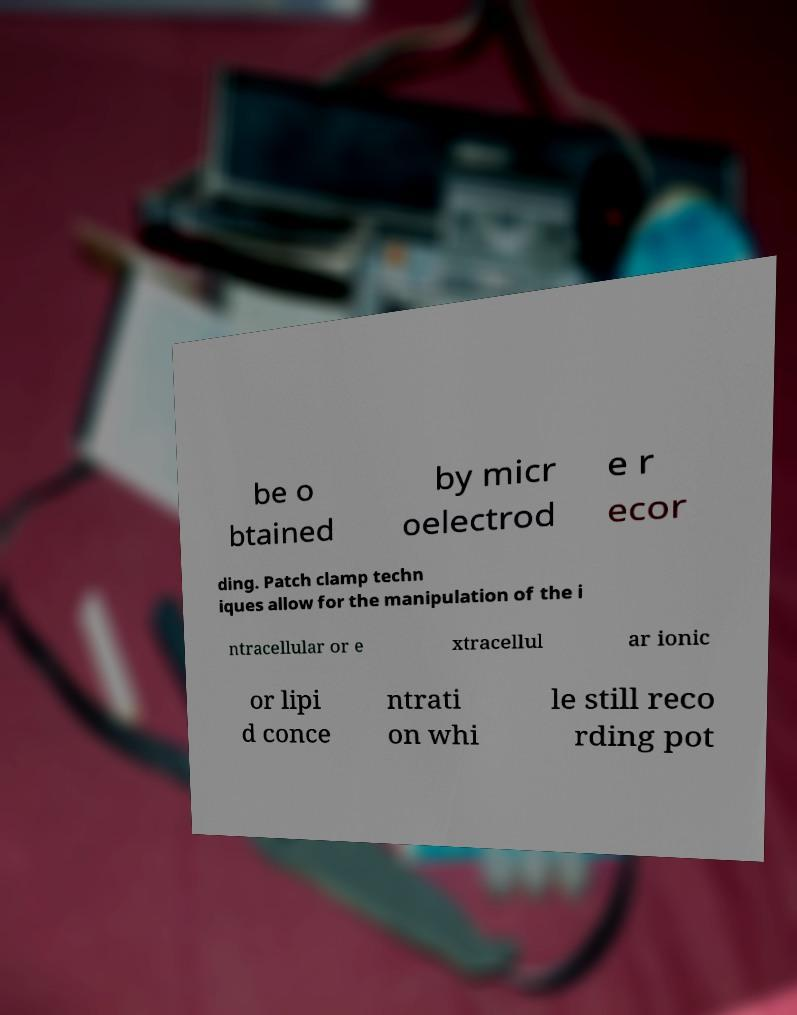For documentation purposes, I need the text within this image transcribed. Could you provide that? be o btained by micr oelectrod e r ecor ding. Patch clamp techn iques allow for the manipulation of the i ntracellular or e xtracellul ar ionic or lipi d conce ntrati on whi le still reco rding pot 